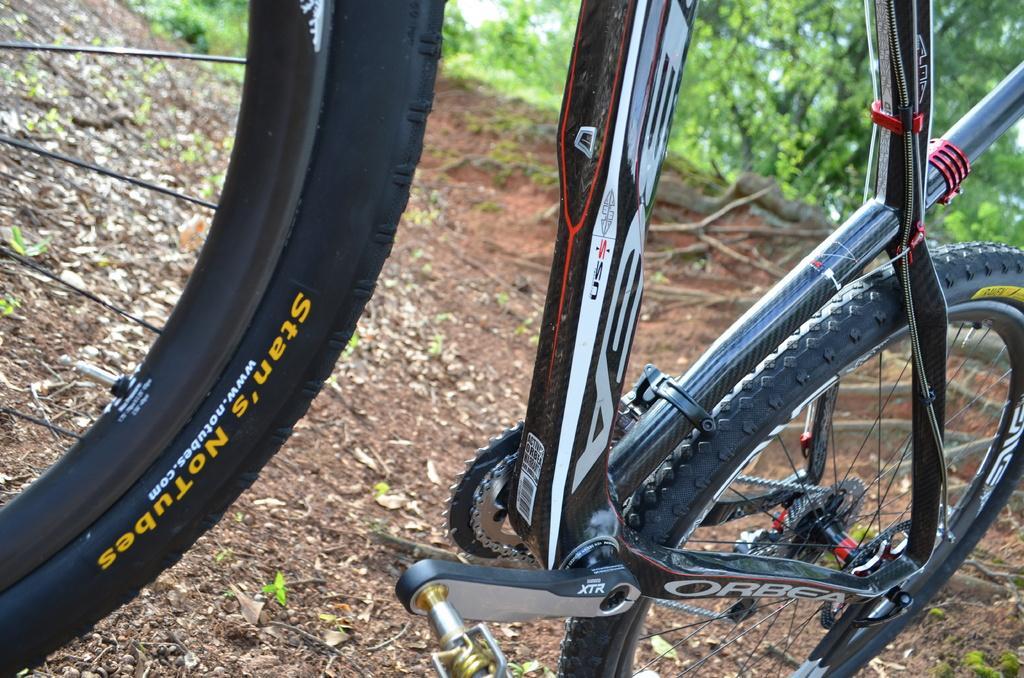In one or two sentences, can you explain what this image depicts? In this image I can see a bicycle, few green trees and few leaves on the ground. 